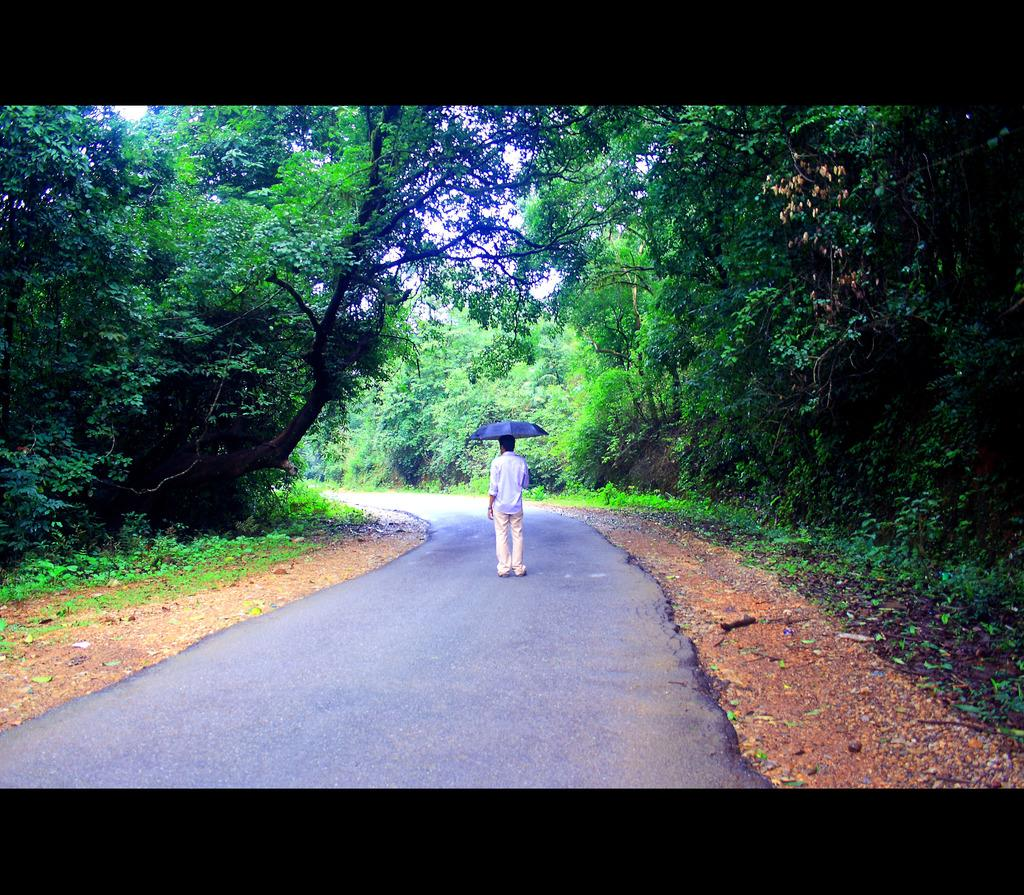What is the person in the image doing? The person is standing on the road. What is the person holding in the image? The person is holding an umbrella. What can be seen in the background of the image? There are plants, trees, and the sky visible in the background of the image. How many cherries are hanging from the person's bag in the image? There is no bag or cherries present in the image. 